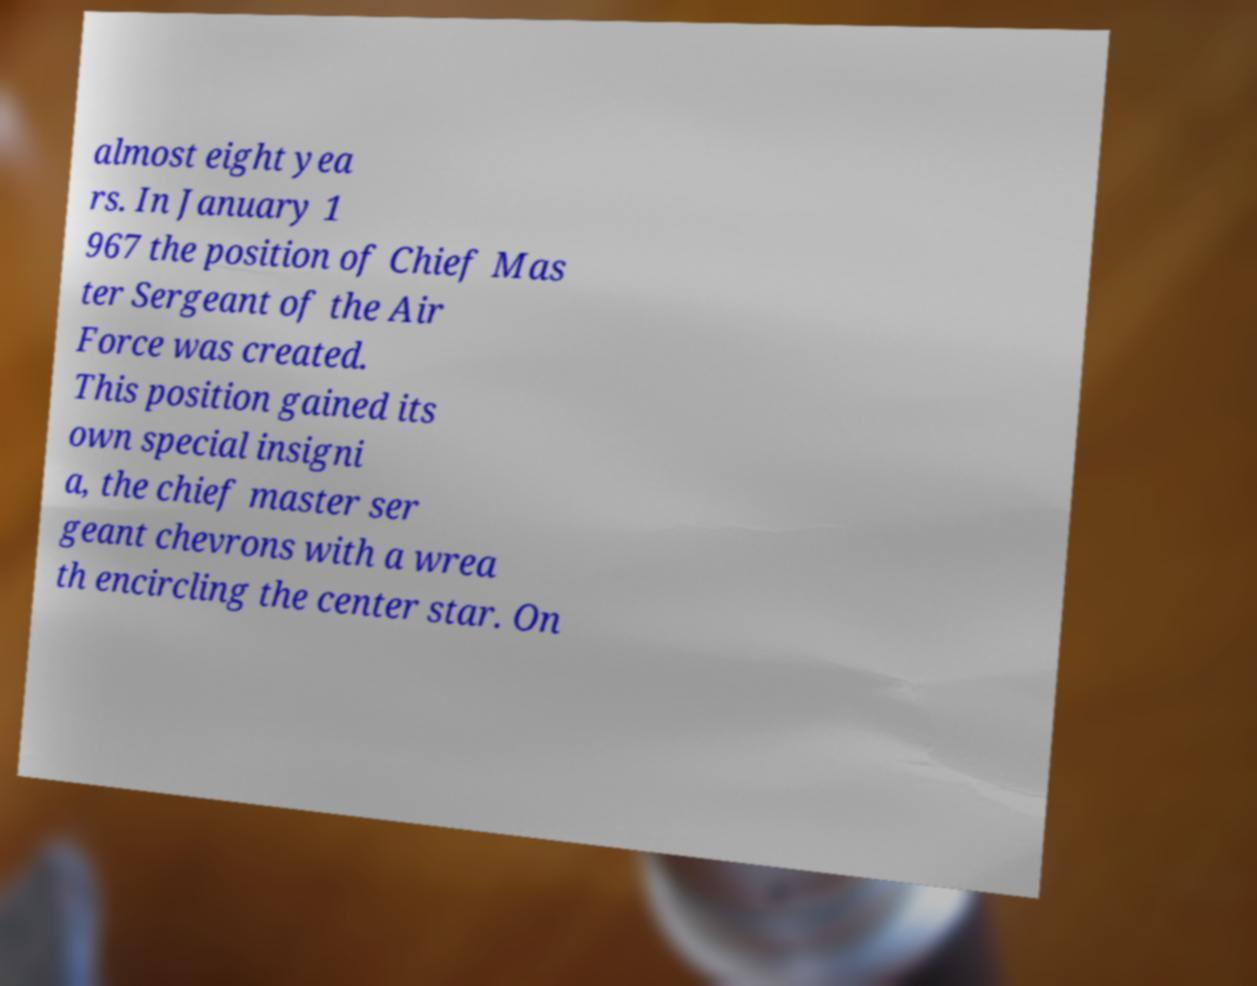Could you extract and type out the text from this image? almost eight yea rs. In January 1 967 the position of Chief Mas ter Sergeant of the Air Force was created. This position gained its own special insigni a, the chief master ser geant chevrons with a wrea th encircling the center star. On 